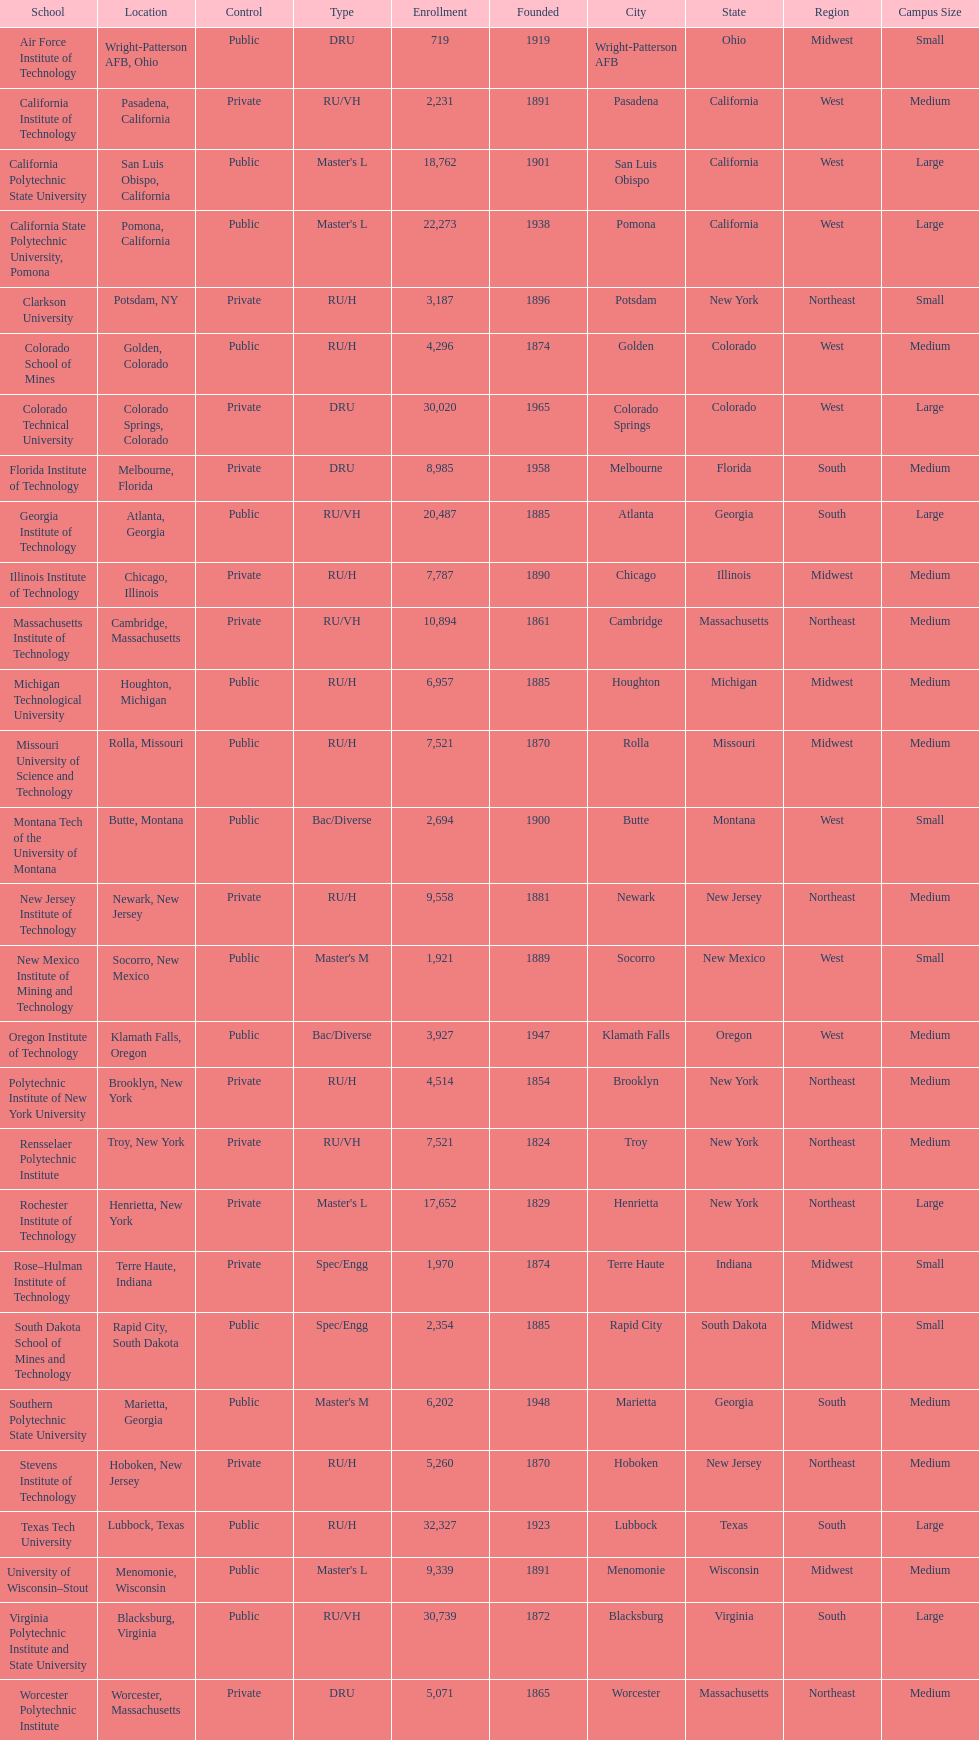Which us technological university has the top enrollment numbers? Texas Tech University. 